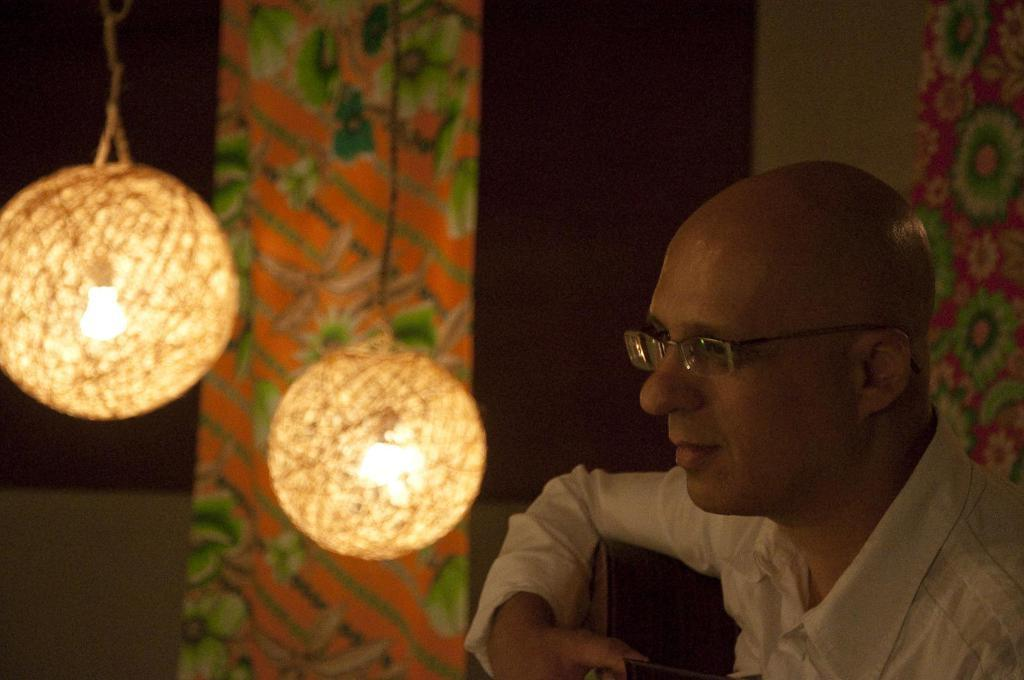Who is present in the image? There is a man in the image. What accessory is the man wearing? The man is wearing spectacles. What can be seen in the background or surroundings of the image? There are lights visible in the image. How many cherries are on the price tag of the tent in the image? There is no tent or price tag with cherries present in the image. 